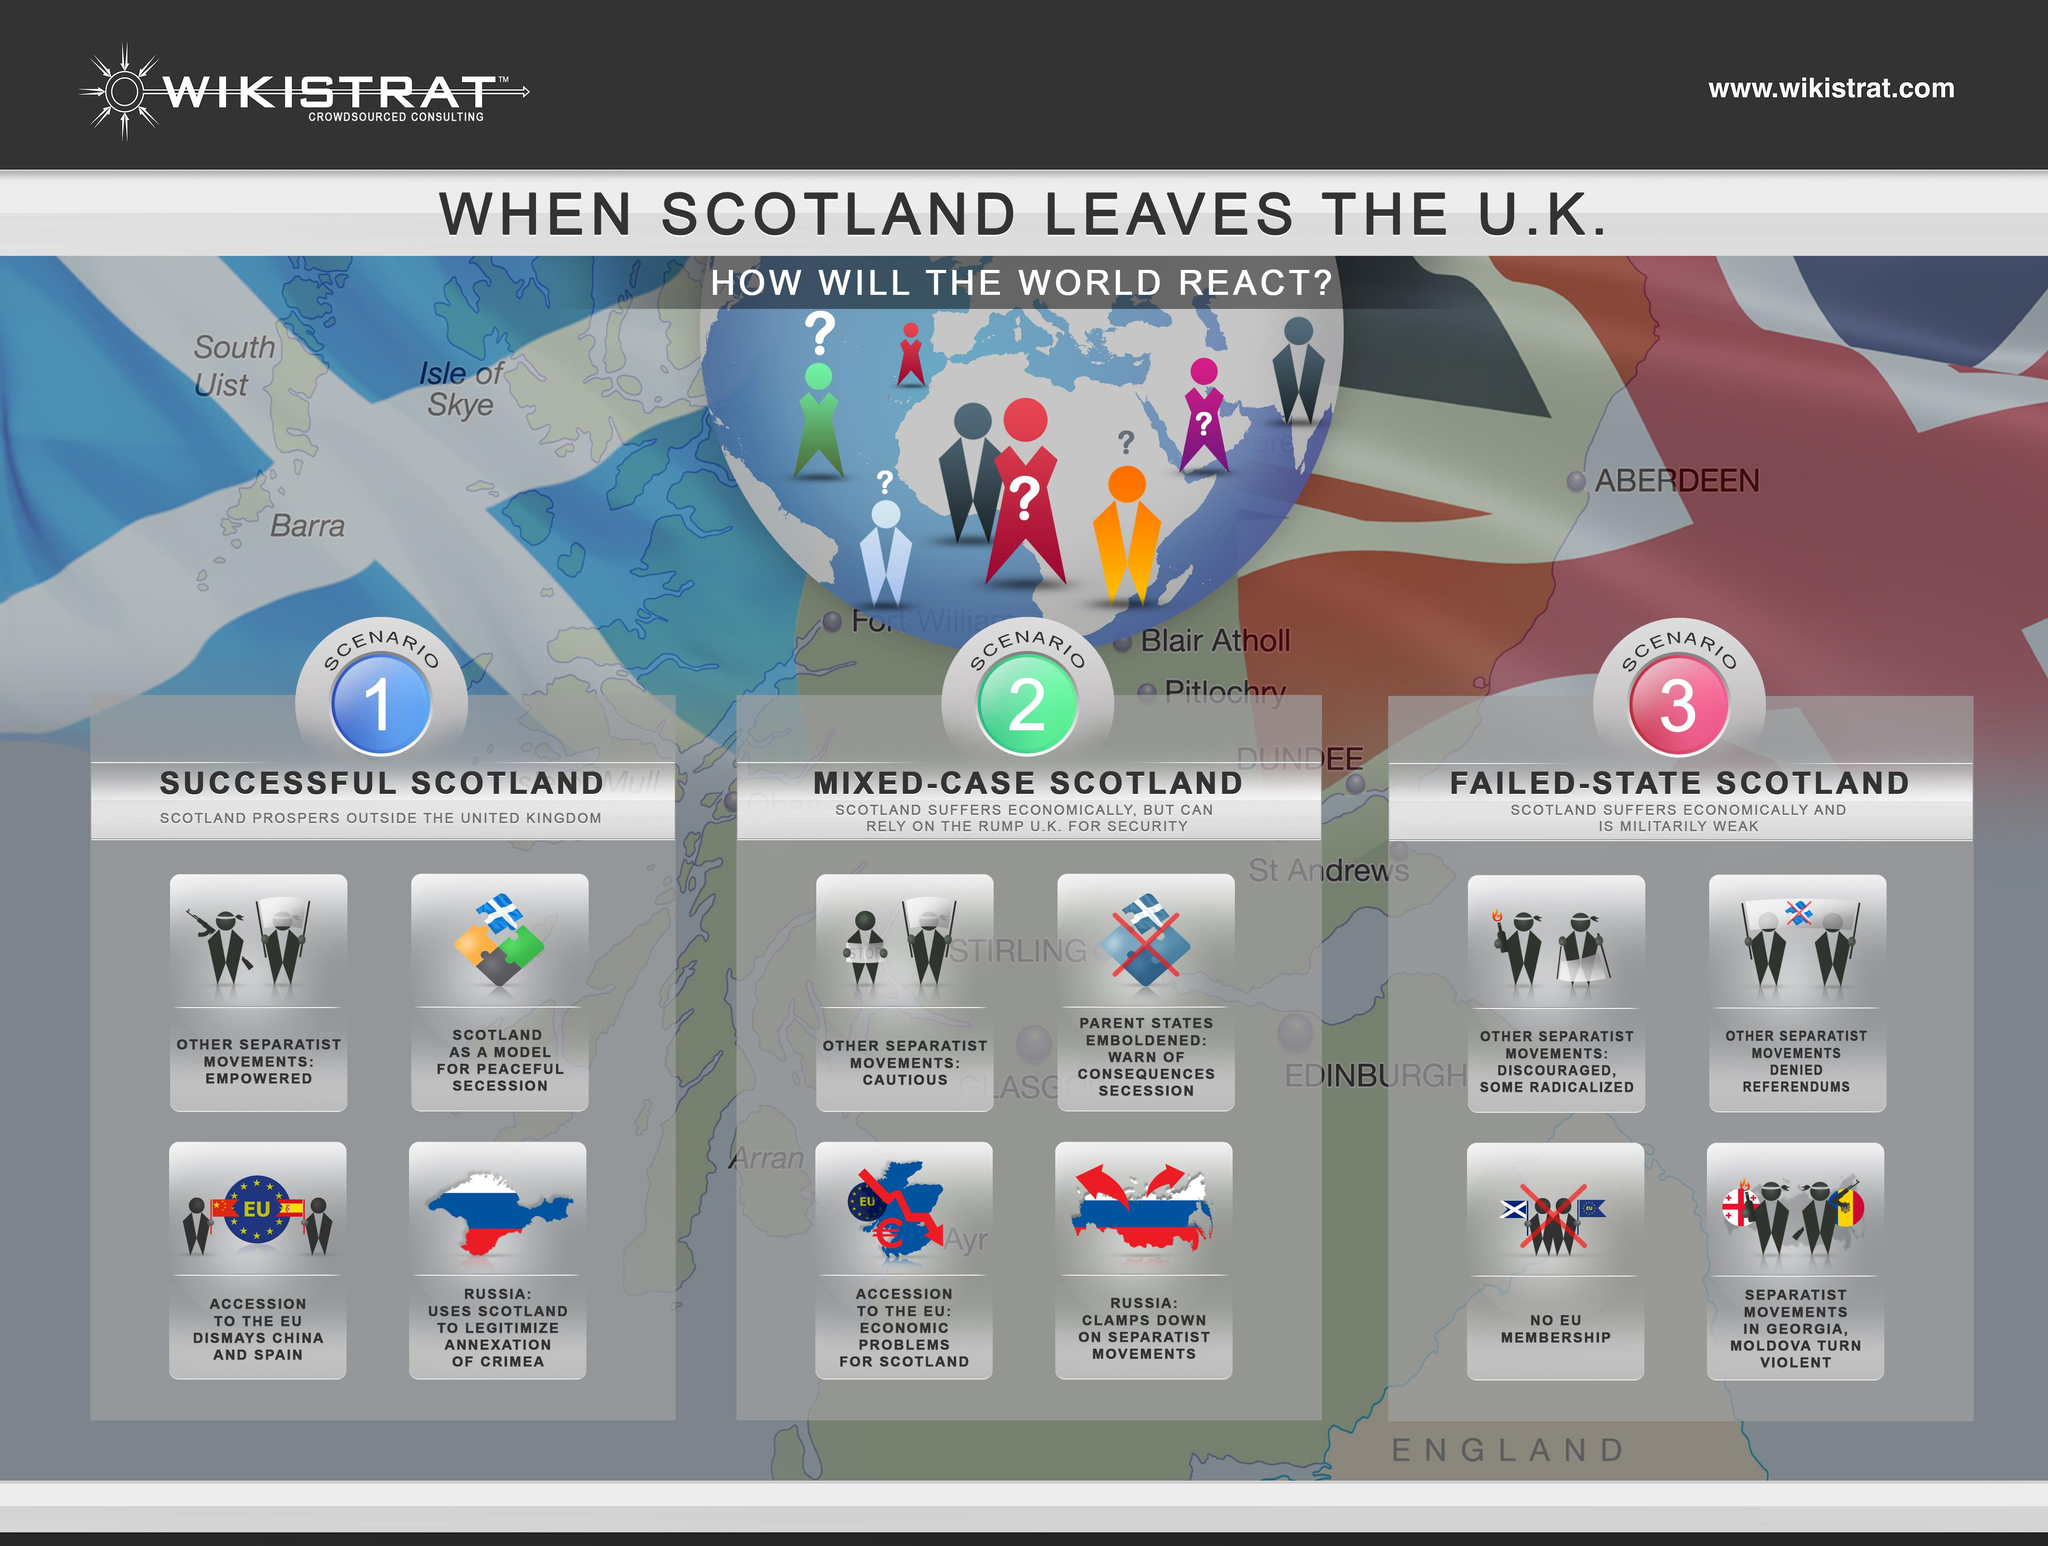Point out several critical features in this image. If Scotland becomes successful in its separatist movement, it is likely that other separatist movements around the world will be empowered. Scotland will suffer economically in scenario 1, 2, and 3. 